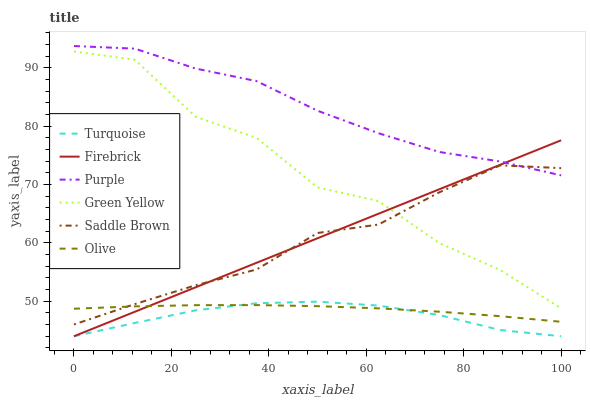Does Turquoise have the minimum area under the curve?
Answer yes or no. Yes. Does Purple have the maximum area under the curve?
Answer yes or no. Yes. Does Firebrick have the minimum area under the curve?
Answer yes or no. No. Does Firebrick have the maximum area under the curve?
Answer yes or no. No. Is Firebrick the smoothest?
Answer yes or no. Yes. Is Green Yellow the roughest?
Answer yes or no. Yes. Is Purple the smoothest?
Answer yes or no. No. Is Purple the roughest?
Answer yes or no. No. Does Turquoise have the lowest value?
Answer yes or no. Yes. Does Purple have the lowest value?
Answer yes or no. No. Does Purple have the highest value?
Answer yes or no. Yes. Does Firebrick have the highest value?
Answer yes or no. No. Is Turquoise less than Green Yellow?
Answer yes or no. Yes. Is Purple greater than Green Yellow?
Answer yes or no. Yes. Does Saddle Brown intersect Green Yellow?
Answer yes or no. Yes. Is Saddle Brown less than Green Yellow?
Answer yes or no. No. Is Saddle Brown greater than Green Yellow?
Answer yes or no. No. Does Turquoise intersect Green Yellow?
Answer yes or no. No. 